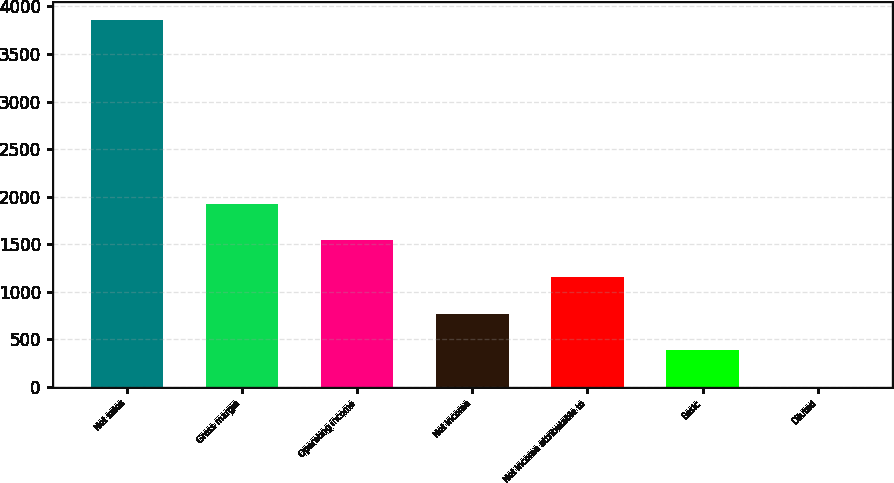Convert chart. <chart><loc_0><loc_0><loc_500><loc_500><bar_chart><fcel>Net sales<fcel>Gross margin<fcel>Operating income<fcel>Net income<fcel>Net income attributable to<fcel>Basic<fcel>Diluted<nl><fcel>3853<fcel>1926.72<fcel>1541.46<fcel>770.94<fcel>1156.2<fcel>385.68<fcel>0.42<nl></chart> 